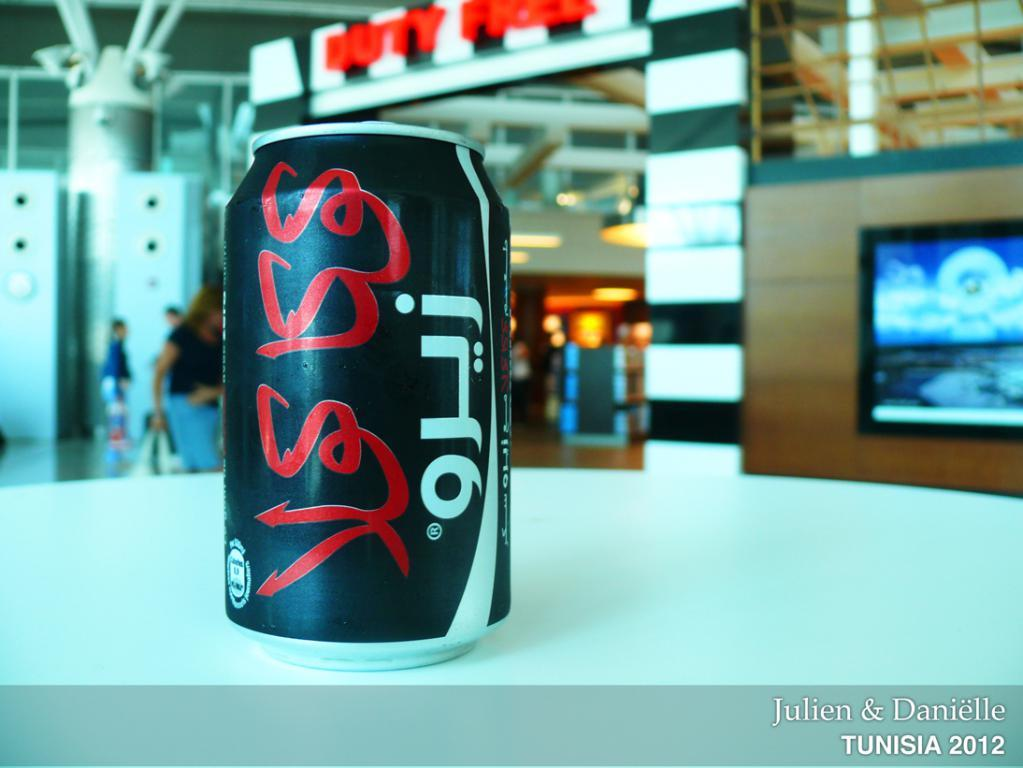Provide a one-sentence caption for the provided image. A photo by Julien & Danielle shows a black can with white and red Arabic writing on a white counter-top. 